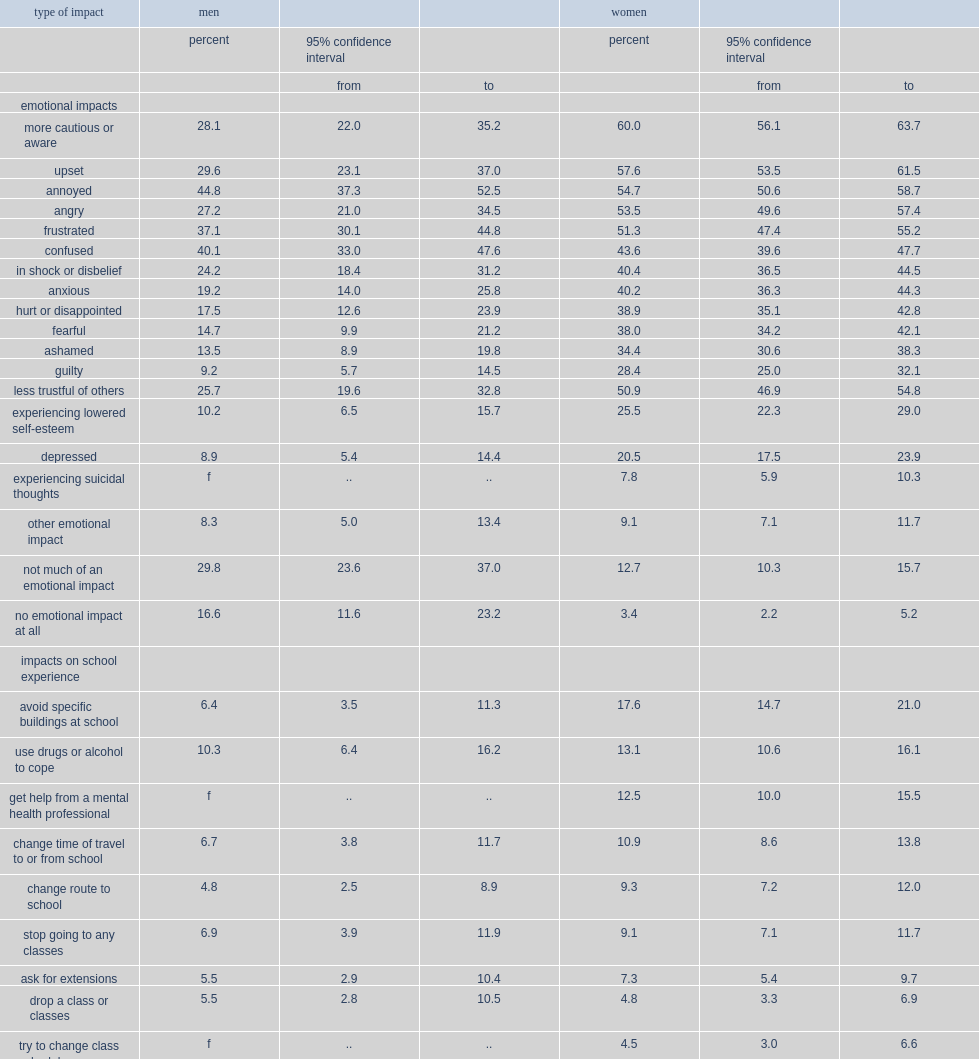How many percnet of women who had been sexually assaulted were also more likely to say that they were fearful? 38.0. How many percent of men who had been sexually assaulted were less likely to say that they were fearful? 14.7. How many percent of women who had been sexually assaulted said the experience had made them more cautious or aware? 60.0. How many percent of men who had been sexually assaulted said the experience had made them more cautious or aware? 28.1. What was the percent of women who were sexually assaulted reported avoiding specific buildings at school? 17.6. What was the percent of women who were sexually assaulted reported changing their route to school? 9.3. The same was true among those who had been sexually assaulted: what was the percent of women reported feeling anxious? 40.2. The same was true among those who had been sexually assaulted: what was the percent of men reported feeling anxious? 19.2. The same was true among those who had been sexually assaulted: how many percent of women reported being depressed? 20.5. The same was true among those who had been sexually assaulted: how many percent of men reported being depressed? 8.9. 